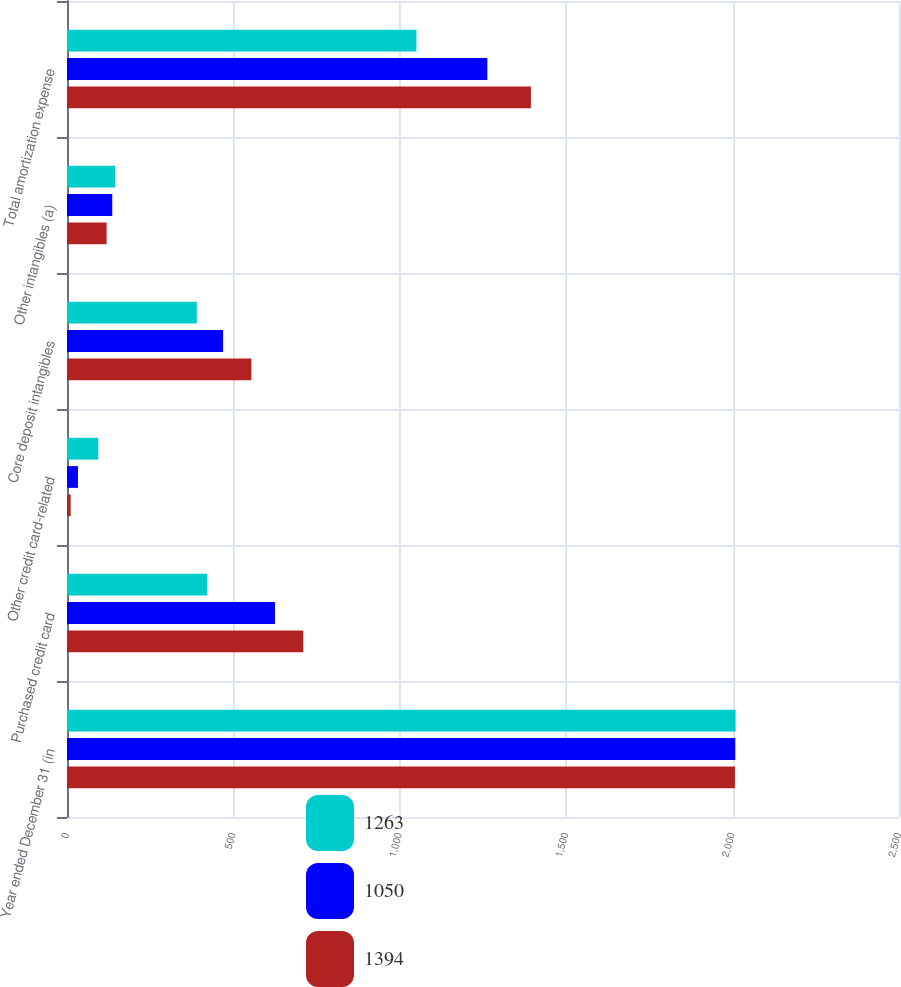Convert chart to OTSL. <chart><loc_0><loc_0><loc_500><loc_500><stacked_bar_chart><ecel><fcel>Year ended December 31 (in<fcel>Purchased credit card<fcel>Other credit card-related<fcel>Core deposit intangibles<fcel>Other intangibles (a)<fcel>Total amortization expense<nl><fcel>1263<fcel>2009<fcel>421<fcel>94<fcel>390<fcel>145<fcel>1050<nl><fcel>1050<fcel>2008<fcel>625<fcel>33<fcel>469<fcel>136<fcel>1263<nl><fcel>1394<fcel>2007<fcel>710<fcel>11<fcel>554<fcel>119<fcel>1394<nl></chart> 